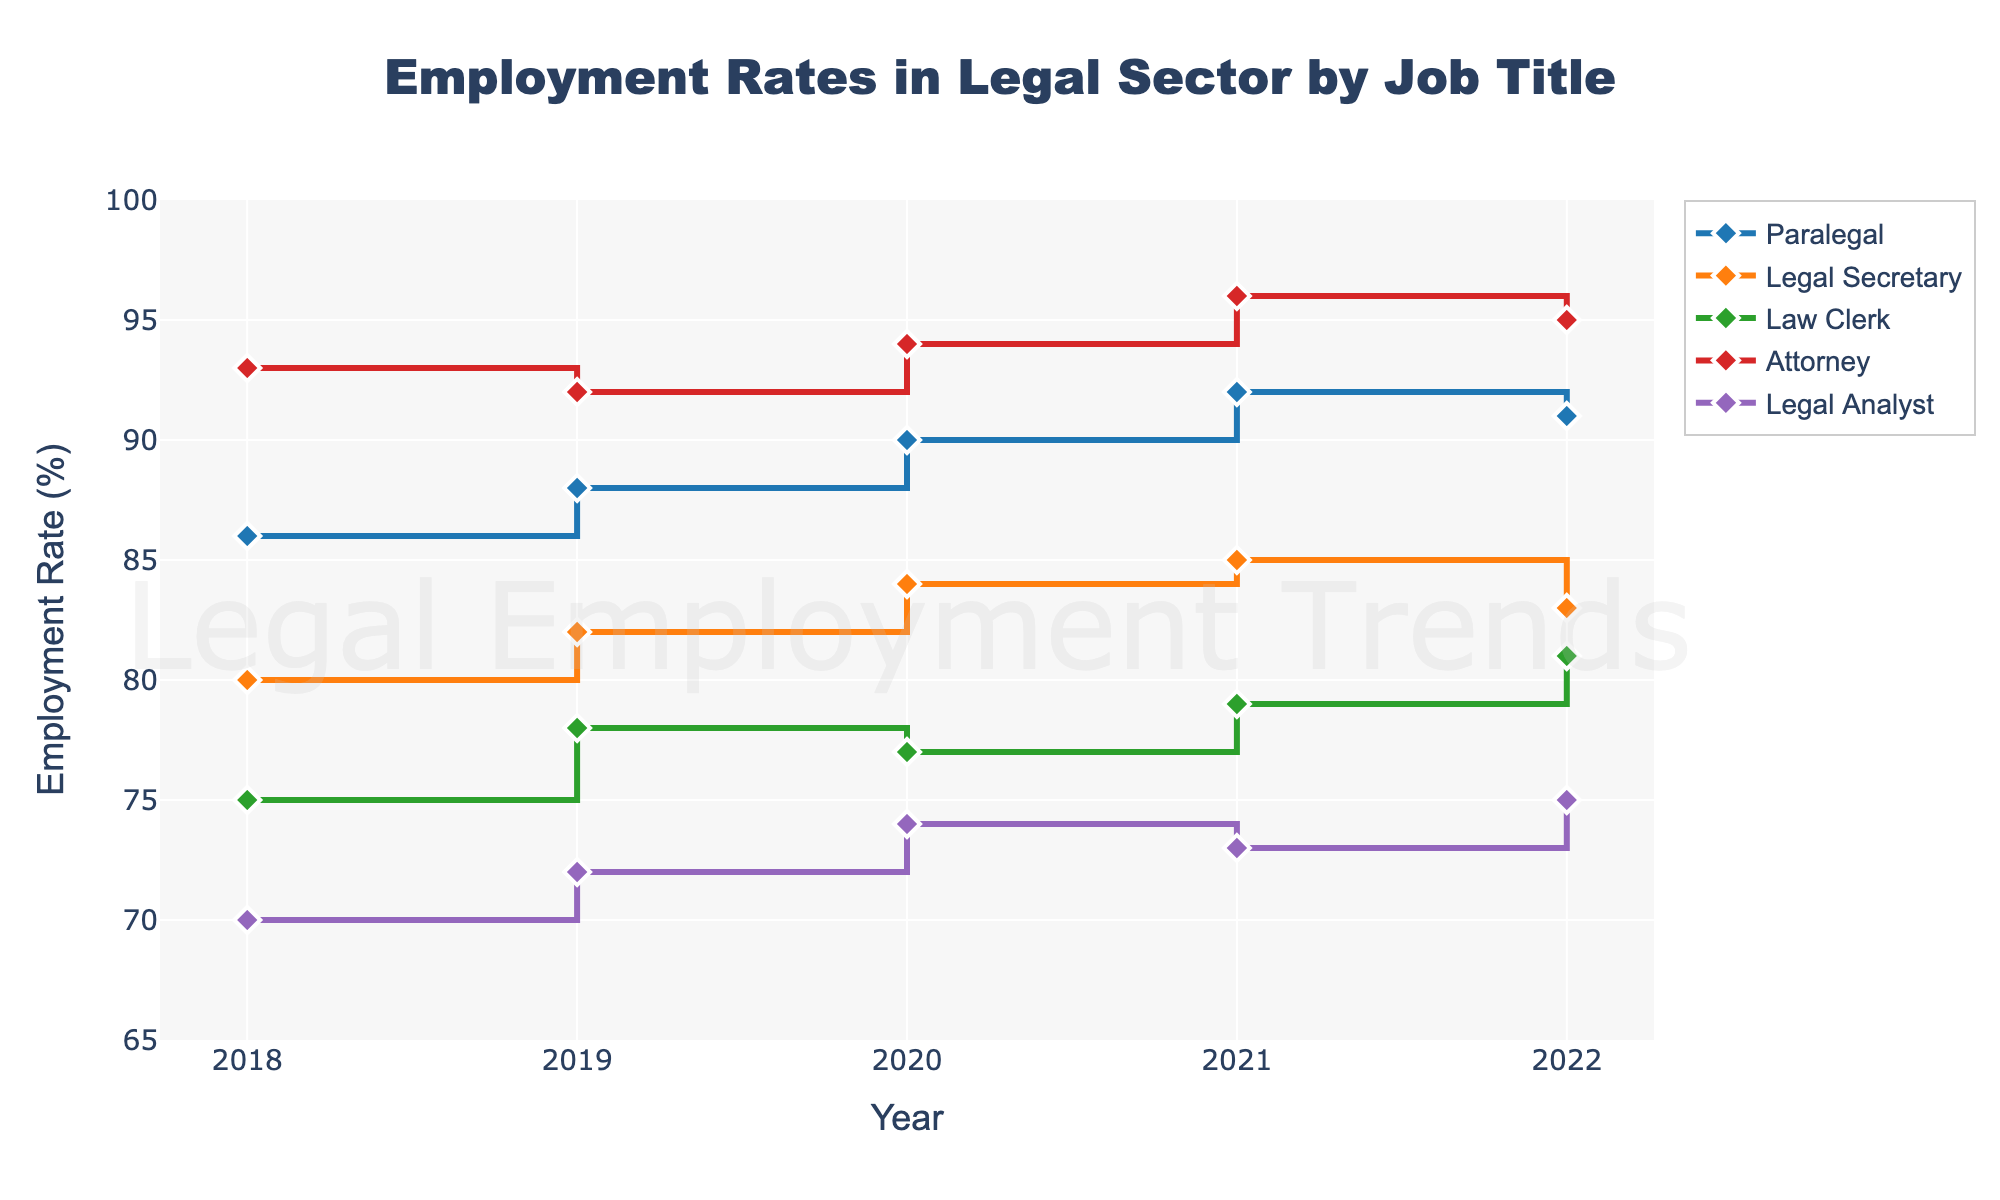Which job title had the highest employment rate in 2022? Looking at the data points for 2022, the highest employment rate is around 95%, and it corresponds to the 'Attorney' job title.
Answer: Attorney How did the employment rate for Paralegals change from 2018 to 2022? Observing the trend from 2018 to 2022 for the 'Paralegal' line, the employment rate increased from 86% in 2018 to 91% in 2022.
Answer: Increased Which job title shows a decrease in employment rate from 2021 to 2022? Checking the data points between 2021 to 2022 for all job titles, 'Legal Secretary' shows a decrease from 85% to 83%.
Answer: Legal Secretary What's the average employment rate for Law Clerks over the 5 years presented? The employment rates for Law Clerks from 2018 to 2022 are 75%, 78%, 77%, 79%, and 81%. Summing these values gives 390%, dividing by 5 gives an average of 78%.
Answer: 78% Between Legal Analysts and Attorneys, which group had a more consistent employment rate from 2018 to 2022? Consistency can be assessed by the variability in their data points. Legal Analysts vary from 70% to 75%, showing a narrower range compared to Attorneys, who vary from 92% to 96%.
Answer: Legal Analysts Did any job title achieve an employment rate of 100%? Observing all the data points across the years and job titles, no job title reached an employment rate of 100%.
Answer: No Comparing 2020, which job title had the lowest employment rate and what was it? Checking the data for 2020, the lowest employment rate was 74% for the 'Legal Analyst' job title.
Answer: Legal Analyst, 74% What is the percent increase in employment rate for Legal Analysts from 2018 to 2022? The employment rate for Legal Analysts in 2018 was 70%, and in 2022 it was 75%. The increase is 75 - 70 = 5%. The percent increase is (5/70)*100 = 7.14%.
Answer: 7.14% Out of the job titles presented, which shows a peak employment rate in 2021? Reviewing the data for 2021, 'Attorney' shows a peak employment rate at 96%.
Answer: Attorney What is the difference in employment rate between Paralegals and Legal Secretaries in 2019? The employment rate for Paralegals in 2019 is 88% and for Legal Secretaries it is 82%. The difference is 88 - 82 = 6%.
Answer: 6% 